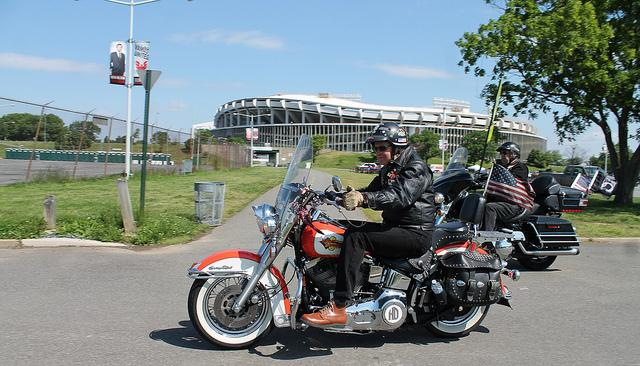What color is the rubber surrounding the outer rim of the tire on these bikes?

Choices:
A) black
B) blue
C) white
D) green white 